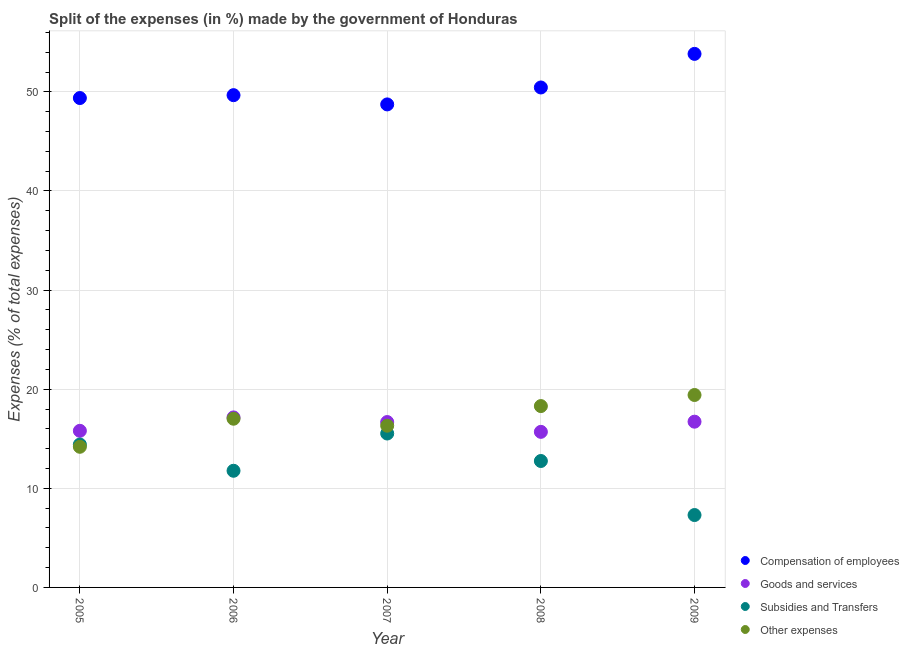How many different coloured dotlines are there?
Provide a short and direct response. 4. Is the number of dotlines equal to the number of legend labels?
Offer a terse response. Yes. What is the percentage of amount spent on subsidies in 2009?
Provide a short and direct response. 7.3. Across all years, what is the maximum percentage of amount spent on other expenses?
Your response must be concise. 19.42. Across all years, what is the minimum percentage of amount spent on subsidies?
Your answer should be compact. 7.3. In which year was the percentage of amount spent on compensation of employees minimum?
Offer a very short reply. 2007. What is the total percentage of amount spent on subsidies in the graph?
Make the answer very short. 61.77. What is the difference between the percentage of amount spent on subsidies in 2005 and that in 2008?
Ensure brevity in your answer.  1.66. What is the difference between the percentage of amount spent on compensation of employees in 2006 and the percentage of amount spent on subsidies in 2008?
Ensure brevity in your answer.  36.91. What is the average percentage of amount spent on goods and services per year?
Provide a short and direct response. 16.41. In the year 2009, what is the difference between the percentage of amount spent on other expenses and percentage of amount spent on goods and services?
Your answer should be compact. 2.69. In how many years, is the percentage of amount spent on goods and services greater than 54 %?
Provide a short and direct response. 0. What is the ratio of the percentage of amount spent on compensation of employees in 2005 to that in 2007?
Give a very brief answer. 1.01. Is the percentage of amount spent on other expenses in 2006 less than that in 2007?
Keep it short and to the point. No. Is the difference between the percentage of amount spent on compensation of employees in 2006 and 2007 greater than the difference between the percentage of amount spent on goods and services in 2006 and 2007?
Keep it short and to the point. Yes. What is the difference between the highest and the second highest percentage of amount spent on other expenses?
Provide a succinct answer. 1.12. What is the difference between the highest and the lowest percentage of amount spent on other expenses?
Give a very brief answer. 5.23. In how many years, is the percentage of amount spent on subsidies greater than the average percentage of amount spent on subsidies taken over all years?
Offer a very short reply. 3. Is it the case that in every year, the sum of the percentage of amount spent on goods and services and percentage of amount spent on other expenses is greater than the sum of percentage of amount spent on compensation of employees and percentage of amount spent on subsidies?
Provide a short and direct response. No. Is it the case that in every year, the sum of the percentage of amount spent on compensation of employees and percentage of amount spent on goods and services is greater than the percentage of amount spent on subsidies?
Offer a terse response. Yes. Does the percentage of amount spent on subsidies monotonically increase over the years?
Offer a terse response. No. Is the percentage of amount spent on subsidies strictly less than the percentage of amount spent on other expenses over the years?
Ensure brevity in your answer.  No. How many dotlines are there?
Keep it short and to the point. 4. How many years are there in the graph?
Make the answer very short. 5. Does the graph contain any zero values?
Your answer should be very brief. No. How many legend labels are there?
Provide a succinct answer. 4. What is the title of the graph?
Your answer should be compact. Split of the expenses (in %) made by the government of Honduras. Does "Interest Payments" appear as one of the legend labels in the graph?
Your answer should be very brief. No. What is the label or title of the X-axis?
Provide a short and direct response. Year. What is the label or title of the Y-axis?
Keep it short and to the point. Expenses (% of total expenses). What is the Expenses (% of total expenses) in Compensation of employees in 2005?
Give a very brief answer. 49.38. What is the Expenses (% of total expenses) in Goods and services in 2005?
Provide a succinct answer. 15.8. What is the Expenses (% of total expenses) of Subsidies and Transfers in 2005?
Your answer should be very brief. 14.42. What is the Expenses (% of total expenses) in Other expenses in 2005?
Provide a short and direct response. 14.19. What is the Expenses (% of total expenses) of Compensation of employees in 2006?
Make the answer very short. 49.67. What is the Expenses (% of total expenses) of Goods and services in 2006?
Ensure brevity in your answer.  17.15. What is the Expenses (% of total expenses) in Subsidies and Transfers in 2006?
Keep it short and to the point. 11.77. What is the Expenses (% of total expenses) in Other expenses in 2006?
Provide a succinct answer. 17.02. What is the Expenses (% of total expenses) in Compensation of employees in 2007?
Keep it short and to the point. 48.73. What is the Expenses (% of total expenses) in Goods and services in 2007?
Your answer should be compact. 16.69. What is the Expenses (% of total expenses) of Subsidies and Transfers in 2007?
Give a very brief answer. 15.53. What is the Expenses (% of total expenses) in Other expenses in 2007?
Offer a very short reply. 16.32. What is the Expenses (% of total expenses) of Compensation of employees in 2008?
Your answer should be very brief. 50.44. What is the Expenses (% of total expenses) in Goods and services in 2008?
Keep it short and to the point. 15.7. What is the Expenses (% of total expenses) of Subsidies and Transfers in 2008?
Provide a short and direct response. 12.76. What is the Expenses (% of total expenses) of Other expenses in 2008?
Make the answer very short. 18.3. What is the Expenses (% of total expenses) of Compensation of employees in 2009?
Provide a succinct answer. 53.83. What is the Expenses (% of total expenses) of Goods and services in 2009?
Make the answer very short. 16.72. What is the Expenses (% of total expenses) in Subsidies and Transfers in 2009?
Offer a terse response. 7.3. What is the Expenses (% of total expenses) in Other expenses in 2009?
Make the answer very short. 19.42. Across all years, what is the maximum Expenses (% of total expenses) in Compensation of employees?
Ensure brevity in your answer.  53.83. Across all years, what is the maximum Expenses (% of total expenses) of Goods and services?
Offer a very short reply. 17.15. Across all years, what is the maximum Expenses (% of total expenses) in Subsidies and Transfers?
Make the answer very short. 15.53. Across all years, what is the maximum Expenses (% of total expenses) in Other expenses?
Give a very brief answer. 19.42. Across all years, what is the minimum Expenses (% of total expenses) in Compensation of employees?
Provide a short and direct response. 48.73. Across all years, what is the minimum Expenses (% of total expenses) of Goods and services?
Provide a succinct answer. 15.7. Across all years, what is the minimum Expenses (% of total expenses) in Subsidies and Transfers?
Your answer should be compact. 7.3. Across all years, what is the minimum Expenses (% of total expenses) in Other expenses?
Ensure brevity in your answer.  14.19. What is the total Expenses (% of total expenses) of Compensation of employees in the graph?
Make the answer very short. 252.05. What is the total Expenses (% of total expenses) in Goods and services in the graph?
Your answer should be very brief. 82.06. What is the total Expenses (% of total expenses) in Subsidies and Transfers in the graph?
Provide a succinct answer. 61.77. What is the total Expenses (% of total expenses) of Other expenses in the graph?
Your answer should be very brief. 85.24. What is the difference between the Expenses (% of total expenses) in Compensation of employees in 2005 and that in 2006?
Offer a terse response. -0.29. What is the difference between the Expenses (% of total expenses) of Goods and services in 2005 and that in 2006?
Ensure brevity in your answer.  -1.35. What is the difference between the Expenses (% of total expenses) in Subsidies and Transfers in 2005 and that in 2006?
Make the answer very short. 2.65. What is the difference between the Expenses (% of total expenses) of Other expenses in 2005 and that in 2006?
Keep it short and to the point. -2.83. What is the difference between the Expenses (% of total expenses) of Compensation of employees in 2005 and that in 2007?
Your answer should be very brief. 0.64. What is the difference between the Expenses (% of total expenses) in Goods and services in 2005 and that in 2007?
Keep it short and to the point. -0.89. What is the difference between the Expenses (% of total expenses) in Subsidies and Transfers in 2005 and that in 2007?
Make the answer very short. -1.11. What is the difference between the Expenses (% of total expenses) of Other expenses in 2005 and that in 2007?
Offer a terse response. -2.13. What is the difference between the Expenses (% of total expenses) of Compensation of employees in 2005 and that in 2008?
Your answer should be compact. -1.06. What is the difference between the Expenses (% of total expenses) in Goods and services in 2005 and that in 2008?
Provide a succinct answer. 0.1. What is the difference between the Expenses (% of total expenses) in Subsidies and Transfers in 2005 and that in 2008?
Offer a very short reply. 1.66. What is the difference between the Expenses (% of total expenses) in Other expenses in 2005 and that in 2008?
Make the answer very short. -4.11. What is the difference between the Expenses (% of total expenses) of Compensation of employees in 2005 and that in 2009?
Provide a succinct answer. -4.46. What is the difference between the Expenses (% of total expenses) in Goods and services in 2005 and that in 2009?
Your answer should be compact. -0.92. What is the difference between the Expenses (% of total expenses) in Subsidies and Transfers in 2005 and that in 2009?
Offer a very short reply. 7.11. What is the difference between the Expenses (% of total expenses) in Other expenses in 2005 and that in 2009?
Make the answer very short. -5.23. What is the difference between the Expenses (% of total expenses) of Compensation of employees in 2006 and that in 2007?
Provide a short and direct response. 0.93. What is the difference between the Expenses (% of total expenses) in Goods and services in 2006 and that in 2007?
Give a very brief answer. 0.47. What is the difference between the Expenses (% of total expenses) of Subsidies and Transfers in 2006 and that in 2007?
Your answer should be very brief. -3.76. What is the difference between the Expenses (% of total expenses) in Other expenses in 2006 and that in 2007?
Offer a terse response. 0.7. What is the difference between the Expenses (% of total expenses) of Compensation of employees in 2006 and that in 2008?
Your response must be concise. -0.77. What is the difference between the Expenses (% of total expenses) in Goods and services in 2006 and that in 2008?
Provide a succinct answer. 1.45. What is the difference between the Expenses (% of total expenses) in Subsidies and Transfers in 2006 and that in 2008?
Your answer should be very brief. -0.99. What is the difference between the Expenses (% of total expenses) of Other expenses in 2006 and that in 2008?
Your answer should be compact. -1.28. What is the difference between the Expenses (% of total expenses) of Compensation of employees in 2006 and that in 2009?
Make the answer very short. -4.16. What is the difference between the Expenses (% of total expenses) in Goods and services in 2006 and that in 2009?
Your answer should be very brief. 0.43. What is the difference between the Expenses (% of total expenses) in Subsidies and Transfers in 2006 and that in 2009?
Ensure brevity in your answer.  4.47. What is the difference between the Expenses (% of total expenses) of Other expenses in 2006 and that in 2009?
Offer a terse response. -2.39. What is the difference between the Expenses (% of total expenses) in Compensation of employees in 2007 and that in 2008?
Your answer should be very brief. -1.71. What is the difference between the Expenses (% of total expenses) of Goods and services in 2007 and that in 2008?
Offer a very short reply. 0.99. What is the difference between the Expenses (% of total expenses) in Subsidies and Transfers in 2007 and that in 2008?
Make the answer very short. 2.77. What is the difference between the Expenses (% of total expenses) in Other expenses in 2007 and that in 2008?
Give a very brief answer. -1.98. What is the difference between the Expenses (% of total expenses) in Compensation of employees in 2007 and that in 2009?
Ensure brevity in your answer.  -5.1. What is the difference between the Expenses (% of total expenses) of Goods and services in 2007 and that in 2009?
Your answer should be compact. -0.04. What is the difference between the Expenses (% of total expenses) of Subsidies and Transfers in 2007 and that in 2009?
Ensure brevity in your answer.  8.22. What is the difference between the Expenses (% of total expenses) of Other expenses in 2007 and that in 2009?
Offer a very short reply. -3.1. What is the difference between the Expenses (% of total expenses) of Compensation of employees in 2008 and that in 2009?
Keep it short and to the point. -3.39. What is the difference between the Expenses (% of total expenses) of Goods and services in 2008 and that in 2009?
Provide a short and direct response. -1.03. What is the difference between the Expenses (% of total expenses) in Subsidies and Transfers in 2008 and that in 2009?
Offer a terse response. 5.45. What is the difference between the Expenses (% of total expenses) in Other expenses in 2008 and that in 2009?
Offer a terse response. -1.12. What is the difference between the Expenses (% of total expenses) of Compensation of employees in 2005 and the Expenses (% of total expenses) of Goods and services in 2006?
Make the answer very short. 32.22. What is the difference between the Expenses (% of total expenses) in Compensation of employees in 2005 and the Expenses (% of total expenses) in Subsidies and Transfers in 2006?
Provide a succinct answer. 37.61. What is the difference between the Expenses (% of total expenses) in Compensation of employees in 2005 and the Expenses (% of total expenses) in Other expenses in 2006?
Make the answer very short. 32.35. What is the difference between the Expenses (% of total expenses) in Goods and services in 2005 and the Expenses (% of total expenses) in Subsidies and Transfers in 2006?
Your answer should be compact. 4.03. What is the difference between the Expenses (% of total expenses) in Goods and services in 2005 and the Expenses (% of total expenses) in Other expenses in 2006?
Give a very brief answer. -1.22. What is the difference between the Expenses (% of total expenses) in Subsidies and Transfers in 2005 and the Expenses (% of total expenses) in Other expenses in 2006?
Your answer should be very brief. -2.6. What is the difference between the Expenses (% of total expenses) of Compensation of employees in 2005 and the Expenses (% of total expenses) of Goods and services in 2007?
Ensure brevity in your answer.  32.69. What is the difference between the Expenses (% of total expenses) of Compensation of employees in 2005 and the Expenses (% of total expenses) of Subsidies and Transfers in 2007?
Ensure brevity in your answer.  33.85. What is the difference between the Expenses (% of total expenses) of Compensation of employees in 2005 and the Expenses (% of total expenses) of Other expenses in 2007?
Offer a terse response. 33.06. What is the difference between the Expenses (% of total expenses) in Goods and services in 2005 and the Expenses (% of total expenses) in Subsidies and Transfers in 2007?
Give a very brief answer. 0.27. What is the difference between the Expenses (% of total expenses) in Goods and services in 2005 and the Expenses (% of total expenses) in Other expenses in 2007?
Keep it short and to the point. -0.52. What is the difference between the Expenses (% of total expenses) in Subsidies and Transfers in 2005 and the Expenses (% of total expenses) in Other expenses in 2007?
Provide a short and direct response. -1.9. What is the difference between the Expenses (% of total expenses) of Compensation of employees in 2005 and the Expenses (% of total expenses) of Goods and services in 2008?
Your answer should be compact. 33.68. What is the difference between the Expenses (% of total expenses) of Compensation of employees in 2005 and the Expenses (% of total expenses) of Subsidies and Transfers in 2008?
Provide a short and direct response. 36.62. What is the difference between the Expenses (% of total expenses) in Compensation of employees in 2005 and the Expenses (% of total expenses) in Other expenses in 2008?
Your answer should be compact. 31.08. What is the difference between the Expenses (% of total expenses) of Goods and services in 2005 and the Expenses (% of total expenses) of Subsidies and Transfers in 2008?
Make the answer very short. 3.04. What is the difference between the Expenses (% of total expenses) in Goods and services in 2005 and the Expenses (% of total expenses) in Other expenses in 2008?
Your answer should be compact. -2.5. What is the difference between the Expenses (% of total expenses) in Subsidies and Transfers in 2005 and the Expenses (% of total expenses) in Other expenses in 2008?
Keep it short and to the point. -3.88. What is the difference between the Expenses (% of total expenses) of Compensation of employees in 2005 and the Expenses (% of total expenses) of Goods and services in 2009?
Give a very brief answer. 32.65. What is the difference between the Expenses (% of total expenses) of Compensation of employees in 2005 and the Expenses (% of total expenses) of Subsidies and Transfers in 2009?
Your response must be concise. 42.07. What is the difference between the Expenses (% of total expenses) in Compensation of employees in 2005 and the Expenses (% of total expenses) in Other expenses in 2009?
Ensure brevity in your answer.  29.96. What is the difference between the Expenses (% of total expenses) of Goods and services in 2005 and the Expenses (% of total expenses) of Subsidies and Transfers in 2009?
Give a very brief answer. 8.5. What is the difference between the Expenses (% of total expenses) of Goods and services in 2005 and the Expenses (% of total expenses) of Other expenses in 2009?
Give a very brief answer. -3.62. What is the difference between the Expenses (% of total expenses) in Subsidies and Transfers in 2005 and the Expenses (% of total expenses) in Other expenses in 2009?
Make the answer very short. -5. What is the difference between the Expenses (% of total expenses) of Compensation of employees in 2006 and the Expenses (% of total expenses) of Goods and services in 2007?
Make the answer very short. 32.98. What is the difference between the Expenses (% of total expenses) of Compensation of employees in 2006 and the Expenses (% of total expenses) of Subsidies and Transfers in 2007?
Provide a short and direct response. 34.14. What is the difference between the Expenses (% of total expenses) of Compensation of employees in 2006 and the Expenses (% of total expenses) of Other expenses in 2007?
Your answer should be compact. 33.35. What is the difference between the Expenses (% of total expenses) of Goods and services in 2006 and the Expenses (% of total expenses) of Subsidies and Transfers in 2007?
Your answer should be compact. 1.62. What is the difference between the Expenses (% of total expenses) of Goods and services in 2006 and the Expenses (% of total expenses) of Other expenses in 2007?
Provide a succinct answer. 0.84. What is the difference between the Expenses (% of total expenses) of Subsidies and Transfers in 2006 and the Expenses (% of total expenses) of Other expenses in 2007?
Make the answer very short. -4.55. What is the difference between the Expenses (% of total expenses) in Compensation of employees in 2006 and the Expenses (% of total expenses) in Goods and services in 2008?
Ensure brevity in your answer.  33.97. What is the difference between the Expenses (% of total expenses) in Compensation of employees in 2006 and the Expenses (% of total expenses) in Subsidies and Transfers in 2008?
Your response must be concise. 36.91. What is the difference between the Expenses (% of total expenses) in Compensation of employees in 2006 and the Expenses (% of total expenses) in Other expenses in 2008?
Make the answer very short. 31.37. What is the difference between the Expenses (% of total expenses) of Goods and services in 2006 and the Expenses (% of total expenses) of Subsidies and Transfers in 2008?
Provide a short and direct response. 4.4. What is the difference between the Expenses (% of total expenses) in Goods and services in 2006 and the Expenses (% of total expenses) in Other expenses in 2008?
Offer a very short reply. -1.15. What is the difference between the Expenses (% of total expenses) in Subsidies and Transfers in 2006 and the Expenses (% of total expenses) in Other expenses in 2008?
Make the answer very short. -6.53. What is the difference between the Expenses (% of total expenses) in Compensation of employees in 2006 and the Expenses (% of total expenses) in Goods and services in 2009?
Ensure brevity in your answer.  32.94. What is the difference between the Expenses (% of total expenses) of Compensation of employees in 2006 and the Expenses (% of total expenses) of Subsidies and Transfers in 2009?
Ensure brevity in your answer.  42.36. What is the difference between the Expenses (% of total expenses) in Compensation of employees in 2006 and the Expenses (% of total expenses) in Other expenses in 2009?
Provide a succinct answer. 30.25. What is the difference between the Expenses (% of total expenses) of Goods and services in 2006 and the Expenses (% of total expenses) of Subsidies and Transfers in 2009?
Keep it short and to the point. 9.85. What is the difference between the Expenses (% of total expenses) in Goods and services in 2006 and the Expenses (% of total expenses) in Other expenses in 2009?
Keep it short and to the point. -2.26. What is the difference between the Expenses (% of total expenses) of Subsidies and Transfers in 2006 and the Expenses (% of total expenses) of Other expenses in 2009?
Offer a very short reply. -7.64. What is the difference between the Expenses (% of total expenses) in Compensation of employees in 2007 and the Expenses (% of total expenses) in Goods and services in 2008?
Your answer should be compact. 33.04. What is the difference between the Expenses (% of total expenses) of Compensation of employees in 2007 and the Expenses (% of total expenses) of Subsidies and Transfers in 2008?
Provide a short and direct response. 35.98. What is the difference between the Expenses (% of total expenses) in Compensation of employees in 2007 and the Expenses (% of total expenses) in Other expenses in 2008?
Provide a short and direct response. 30.44. What is the difference between the Expenses (% of total expenses) in Goods and services in 2007 and the Expenses (% of total expenses) in Subsidies and Transfers in 2008?
Your response must be concise. 3.93. What is the difference between the Expenses (% of total expenses) in Goods and services in 2007 and the Expenses (% of total expenses) in Other expenses in 2008?
Provide a short and direct response. -1.61. What is the difference between the Expenses (% of total expenses) in Subsidies and Transfers in 2007 and the Expenses (% of total expenses) in Other expenses in 2008?
Provide a short and direct response. -2.77. What is the difference between the Expenses (% of total expenses) in Compensation of employees in 2007 and the Expenses (% of total expenses) in Goods and services in 2009?
Provide a succinct answer. 32.01. What is the difference between the Expenses (% of total expenses) in Compensation of employees in 2007 and the Expenses (% of total expenses) in Subsidies and Transfers in 2009?
Keep it short and to the point. 41.43. What is the difference between the Expenses (% of total expenses) of Compensation of employees in 2007 and the Expenses (% of total expenses) of Other expenses in 2009?
Keep it short and to the point. 29.32. What is the difference between the Expenses (% of total expenses) of Goods and services in 2007 and the Expenses (% of total expenses) of Subsidies and Transfers in 2009?
Your response must be concise. 9.38. What is the difference between the Expenses (% of total expenses) in Goods and services in 2007 and the Expenses (% of total expenses) in Other expenses in 2009?
Make the answer very short. -2.73. What is the difference between the Expenses (% of total expenses) in Subsidies and Transfers in 2007 and the Expenses (% of total expenses) in Other expenses in 2009?
Make the answer very short. -3.89. What is the difference between the Expenses (% of total expenses) in Compensation of employees in 2008 and the Expenses (% of total expenses) in Goods and services in 2009?
Make the answer very short. 33.72. What is the difference between the Expenses (% of total expenses) of Compensation of employees in 2008 and the Expenses (% of total expenses) of Subsidies and Transfers in 2009?
Make the answer very short. 43.14. What is the difference between the Expenses (% of total expenses) in Compensation of employees in 2008 and the Expenses (% of total expenses) in Other expenses in 2009?
Keep it short and to the point. 31.03. What is the difference between the Expenses (% of total expenses) of Goods and services in 2008 and the Expenses (% of total expenses) of Subsidies and Transfers in 2009?
Ensure brevity in your answer.  8.39. What is the difference between the Expenses (% of total expenses) of Goods and services in 2008 and the Expenses (% of total expenses) of Other expenses in 2009?
Keep it short and to the point. -3.72. What is the difference between the Expenses (% of total expenses) in Subsidies and Transfers in 2008 and the Expenses (% of total expenses) in Other expenses in 2009?
Give a very brief answer. -6.66. What is the average Expenses (% of total expenses) in Compensation of employees per year?
Your answer should be very brief. 50.41. What is the average Expenses (% of total expenses) in Goods and services per year?
Offer a terse response. 16.41. What is the average Expenses (% of total expenses) in Subsidies and Transfers per year?
Offer a terse response. 12.36. What is the average Expenses (% of total expenses) in Other expenses per year?
Give a very brief answer. 17.05. In the year 2005, what is the difference between the Expenses (% of total expenses) in Compensation of employees and Expenses (% of total expenses) in Goods and services?
Your answer should be compact. 33.58. In the year 2005, what is the difference between the Expenses (% of total expenses) in Compensation of employees and Expenses (% of total expenses) in Subsidies and Transfers?
Your response must be concise. 34.96. In the year 2005, what is the difference between the Expenses (% of total expenses) in Compensation of employees and Expenses (% of total expenses) in Other expenses?
Your response must be concise. 35.19. In the year 2005, what is the difference between the Expenses (% of total expenses) of Goods and services and Expenses (% of total expenses) of Subsidies and Transfers?
Keep it short and to the point. 1.38. In the year 2005, what is the difference between the Expenses (% of total expenses) in Goods and services and Expenses (% of total expenses) in Other expenses?
Give a very brief answer. 1.61. In the year 2005, what is the difference between the Expenses (% of total expenses) in Subsidies and Transfers and Expenses (% of total expenses) in Other expenses?
Make the answer very short. 0.23. In the year 2006, what is the difference between the Expenses (% of total expenses) of Compensation of employees and Expenses (% of total expenses) of Goods and services?
Offer a very short reply. 32.52. In the year 2006, what is the difference between the Expenses (% of total expenses) of Compensation of employees and Expenses (% of total expenses) of Subsidies and Transfers?
Your answer should be very brief. 37.9. In the year 2006, what is the difference between the Expenses (% of total expenses) in Compensation of employees and Expenses (% of total expenses) in Other expenses?
Your answer should be very brief. 32.65. In the year 2006, what is the difference between the Expenses (% of total expenses) in Goods and services and Expenses (% of total expenses) in Subsidies and Transfers?
Provide a succinct answer. 5.38. In the year 2006, what is the difference between the Expenses (% of total expenses) of Goods and services and Expenses (% of total expenses) of Other expenses?
Provide a succinct answer. 0.13. In the year 2006, what is the difference between the Expenses (% of total expenses) of Subsidies and Transfers and Expenses (% of total expenses) of Other expenses?
Provide a short and direct response. -5.25. In the year 2007, what is the difference between the Expenses (% of total expenses) in Compensation of employees and Expenses (% of total expenses) in Goods and services?
Give a very brief answer. 32.05. In the year 2007, what is the difference between the Expenses (% of total expenses) of Compensation of employees and Expenses (% of total expenses) of Subsidies and Transfers?
Your response must be concise. 33.2. In the year 2007, what is the difference between the Expenses (% of total expenses) in Compensation of employees and Expenses (% of total expenses) in Other expenses?
Give a very brief answer. 32.42. In the year 2007, what is the difference between the Expenses (% of total expenses) of Goods and services and Expenses (% of total expenses) of Subsidies and Transfers?
Keep it short and to the point. 1.16. In the year 2007, what is the difference between the Expenses (% of total expenses) in Goods and services and Expenses (% of total expenses) in Other expenses?
Provide a succinct answer. 0.37. In the year 2007, what is the difference between the Expenses (% of total expenses) of Subsidies and Transfers and Expenses (% of total expenses) of Other expenses?
Ensure brevity in your answer.  -0.79. In the year 2008, what is the difference between the Expenses (% of total expenses) in Compensation of employees and Expenses (% of total expenses) in Goods and services?
Your answer should be compact. 34.74. In the year 2008, what is the difference between the Expenses (% of total expenses) in Compensation of employees and Expenses (% of total expenses) in Subsidies and Transfers?
Keep it short and to the point. 37.69. In the year 2008, what is the difference between the Expenses (% of total expenses) in Compensation of employees and Expenses (% of total expenses) in Other expenses?
Provide a succinct answer. 32.14. In the year 2008, what is the difference between the Expenses (% of total expenses) of Goods and services and Expenses (% of total expenses) of Subsidies and Transfers?
Keep it short and to the point. 2.94. In the year 2008, what is the difference between the Expenses (% of total expenses) in Goods and services and Expenses (% of total expenses) in Other expenses?
Your answer should be compact. -2.6. In the year 2008, what is the difference between the Expenses (% of total expenses) in Subsidies and Transfers and Expenses (% of total expenses) in Other expenses?
Your answer should be very brief. -5.54. In the year 2009, what is the difference between the Expenses (% of total expenses) of Compensation of employees and Expenses (% of total expenses) of Goods and services?
Offer a very short reply. 37.11. In the year 2009, what is the difference between the Expenses (% of total expenses) of Compensation of employees and Expenses (% of total expenses) of Subsidies and Transfers?
Your response must be concise. 46.53. In the year 2009, what is the difference between the Expenses (% of total expenses) of Compensation of employees and Expenses (% of total expenses) of Other expenses?
Offer a very short reply. 34.42. In the year 2009, what is the difference between the Expenses (% of total expenses) of Goods and services and Expenses (% of total expenses) of Subsidies and Transfers?
Offer a terse response. 9.42. In the year 2009, what is the difference between the Expenses (% of total expenses) in Goods and services and Expenses (% of total expenses) in Other expenses?
Provide a succinct answer. -2.69. In the year 2009, what is the difference between the Expenses (% of total expenses) of Subsidies and Transfers and Expenses (% of total expenses) of Other expenses?
Your answer should be compact. -12.11. What is the ratio of the Expenses (% of total expenses) in Goods and services in 2005 to that in 2006?
Make the answer very short. 0.92. What is the ratio of the Expenses (% of total expenses) in Subsidies and Transfers in 2005 to that in 2006?
Give a very brief answer. 1.22. What is the ratio of the Expenses (% of total expenses) in Other expenses in 2005 to that in 2006?
Offer a terse response. 0.83. What is the ratio of the Expenses (% of total expenses) of Compensation of employees in 2005 to that in 2007?
Your answer should be compact. 1.01. What is the ratio of the Expenses (% of total expenses) in Goods and services in 2005 to that in 2007?
Your answer should be very brief. 0.95. What is the ratio of the Expenses (% of total expenses) in Subsidies and Transfers in 2005 to that in 2007?
Keep it short and to the point. 0.93. What is the ratio of the Expenses (% of total expenses) in Other expenses in 2005 to that in 2007?
Provide a short and direct response. 0.87. What is the ratio of the Expenses (% of total expenses) of Compensation of employees in 2005 to that in 2008?
Give a very brief answer. 0.98. What is the ratio of the Expenses (% of total expenses) of Goods and services in 2005 to that in 2008?
Your answer should be compact. 1.01. What is the ratio of the Expenses (% of total expenses) in Subsidies and Transfers in 2005 to that in 2008?
Your answer should be compact. 1.13. What is the ratio of the Expenses (% of total expenses) in Other expenses in 2005 to that in 2008?
Your response must be concise. 0.78. What is the ratio of the Expenses (% of total expenses) of Compensation of employees in 2005 to that in 2009?
Your response must be concise. 0.92. What is the ratio of the Expenses (% of total expenses) in Goods and services in 2005 to that in 2009?
Your answer should be compact. 0.94. What is the ratio of the Expenses (% of total expenses) of Subsidies and Transfers in 2005 to that in 2009?
Make the answer very short. 1.97. What is the ratio of the Expenses (% of total expenses) of Other expenses in 2005 to that in 2009?
Provide a succinct answer. 0.73. What is the ratio of the Expenses (% of total expenses) of Compensation of employees in 2006 to that in 2007?
Provide a short and direct response. 1.02. What is the ratio of the Expenses (% of total expenses) in Goods and services in 2006 to that in 2007?
Provide a short and direct response. 1.03. What is the ratio of the Expenses (% of total expenses) in Subsidies and Transfers in 2006 to that in 2007?
Ensure brevity in your answer.  0.76. What is the ratio of the Expenses (% of total expenses) in Other expenses in 2006 to that in 2007?
Make the answer very short. 1.04. What is the ratio of the Expenses (% of total expenses) in Compensation of employees in 2006 to that in 2008?
Ensure brevity in your answer.  0.98. What is the ratio of the Expenses (% of total expenses) in Goods and services in 2006 to that in 2008?
Keep it short and to the point. 1.09. What is the ratio of the Expenses (% of total expenses) of Subsidies and Transfers in 2006 to that in 2008?
Make the answer very short. 0.92. What is the ratio of the Expenses (% of total expenses) of Other expenses in 2006 to that in 2008?
Keep it short and to the point. 0.93. What is the ratio of the Expenses (% of total expenses) in Compensation of employees in 2006 to that in 2009?
Ensure brevity in your answer.  0.92. What is the ratio of the Expenses (% of total expenses) of Goods and services in 2006 to that in 2009?
Your response must be concise. 1.03. What is the ratio of the Expenses (% of total expenses) in Subsidies and Transfers in 2006 to that in 2009?
Your answer should be compact. 1.61. What is the ratio of the Expenses (% of total expenses) of Other expenses in 2006 to that in 2009?
Ensure brevity in your answer.  0.88. What is the ratio of the Expenses (% of total expenses) in Compensation of employees in 2007 to that in 2008?
Offer a terse response. 0.97. What is the ratio of the Expenses (% of total expenses) of Goods and services in 2007 to that in 2008?
Provide a short and direct response. 1.06. What is the ratio of the Expenses (% of total expenses) in Subsidies and Transfers in 2007 to that in 2008?
Your answer should be very brief. 1.22. What is the ratio of the Expenses (% of total expenses) in Other expenses in 2007 to that in 2008?
Ensure brevity in your answer.  0.89. What is the ratio of the Expenses (% of total expenses) of Compensation of employees in 2007 to that in 2009?
Your answer should be very brief. 0.91. What is the ratio of the Expenses (% of total expenses) of Goods and services in 2007 to that in 2009?
Offer a terse response. 1. What is the ratio of the Expenses (% of total expenses) of Subsidies and Transfers in 2007 to that in 2009?
Your answer should be very brief. 2.13. What is the ratio of the Expenses (% of total expenses) of Other expenses in 2007 to that in 2009?
Give a very brief answer. 0.84. What is the ratio of the Expenses (% of total expenses) of Compensation of employees in 2008 to that in 2009?
Your response must be concise. 0.94. What is the ratio of the Expenses (% of total expenses) in Goods and services in 2008 to that in 2009?
Your answer should be very brief. 0.94. What is the ratio of the Expenses (% of total expenses) of Subsidies and Transfers in 2008 to that in 2009?
Provide a succinct answer. 1.75. What is the ratio of the Expenses (% of total expenses) in Other expenses in 2008 to that in 2009?
Your answer should be very brief. 0.94. What is the difference between the highest and the second highest Expenses (% of total expenses) in Compensation of employees?
Provide a short and direct response. 3.39. What is the difference between the highest and the second highest Expenses (% of total expenses) in Goods and services?
Provide a short and direct response. 0.43. What is the difference between the highest and the second highest Expenses (% of total expenses) of Subsidies and Transfers?
Provide a succinct answer. 1.11. What is the difference between the highest and the second highest Expenses (% of total expenses) of Other expenses?
Offer a terse response. 1.12. What is the difference between the highest and the lowest Expenses (% of total expenses) of Compensation of employees?
Offer a terse response. 5.1. What is the difference between the highest and the lowest Expenses (% of total expenses) of Goods and services?
Give a very brief answer. 1.45. What is the difference between the highest and the lowest Expenses (% of total expenses) of Subsidies and Transfers?
Your answer should be very brief. 8.22. What is the difference between the highest and the lowest Expenses (% of total expenses) of Other expenses?
Give a very brief answer. 5.23. 